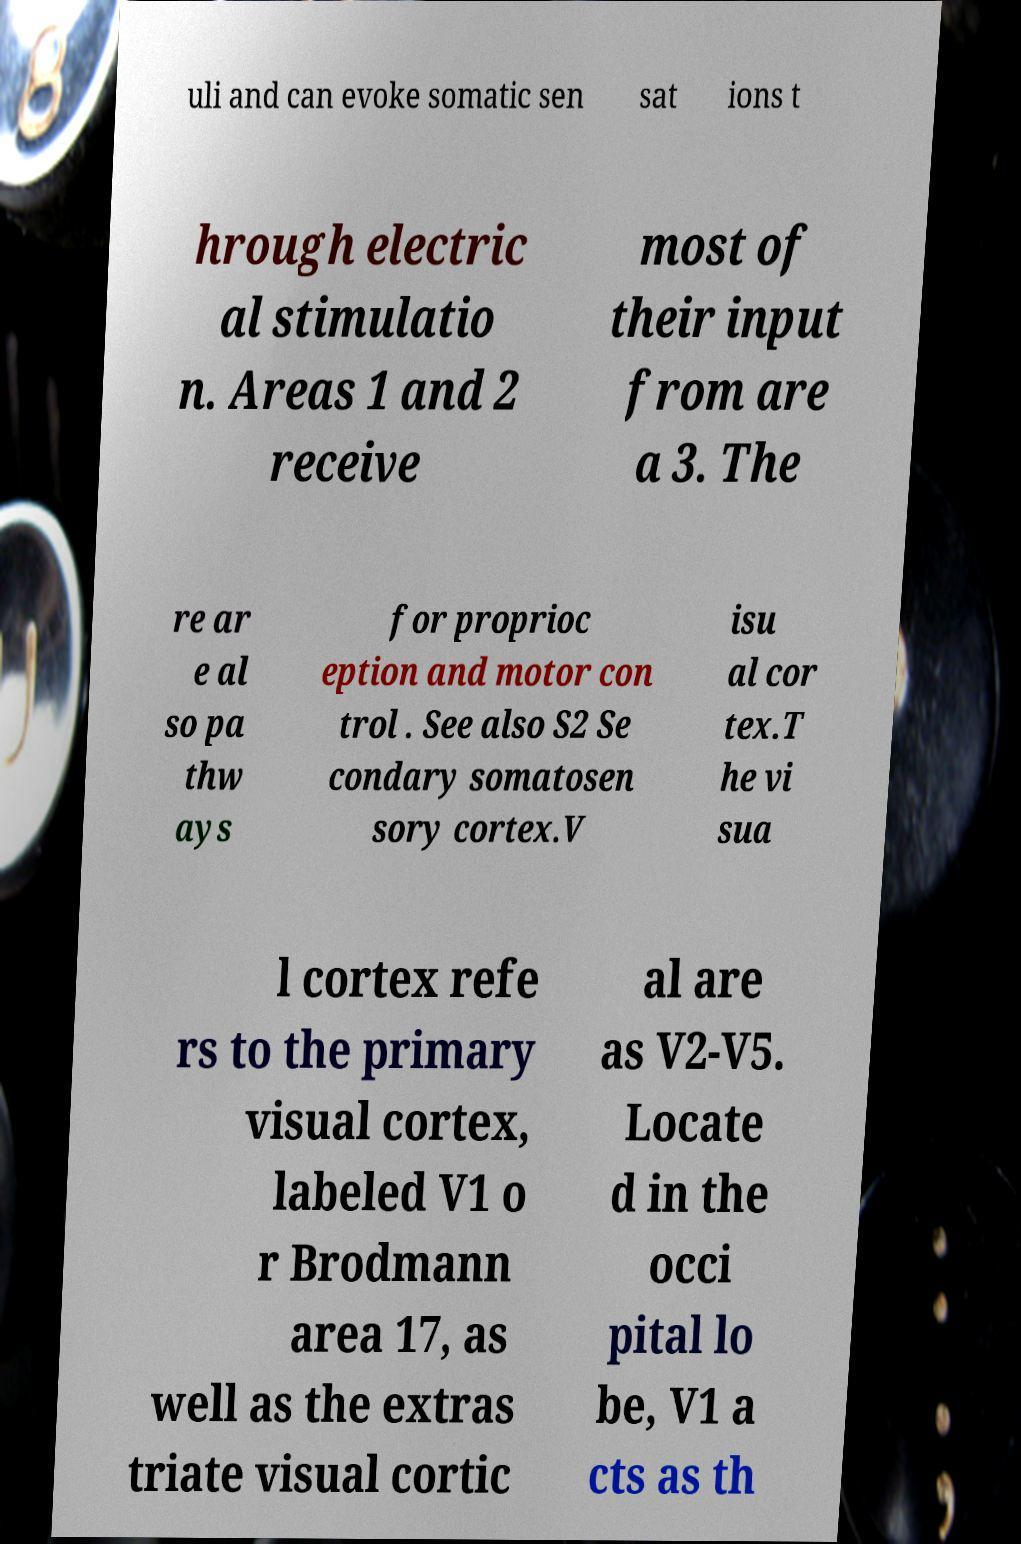Please read and relay the text visible in this image. What does it say? uli and can evoke somatic sen sat ions t hrough electric al stimulatio n. Areas 1 and 2 receive most of their input from are a 3. The re ar e al so pa thw ays for proprioc eption and motor con trol . See also S2 Se condary somatosen sory cortex.V isu al cor tex.T he vi sua l cortex refe rs to the primary visual cortex, labeled V1 o r Brodmann area 17, as well as the extras triate visual cortic al are as V2-V5. Locate d in the occi pital lo be, V1 a cts as th 